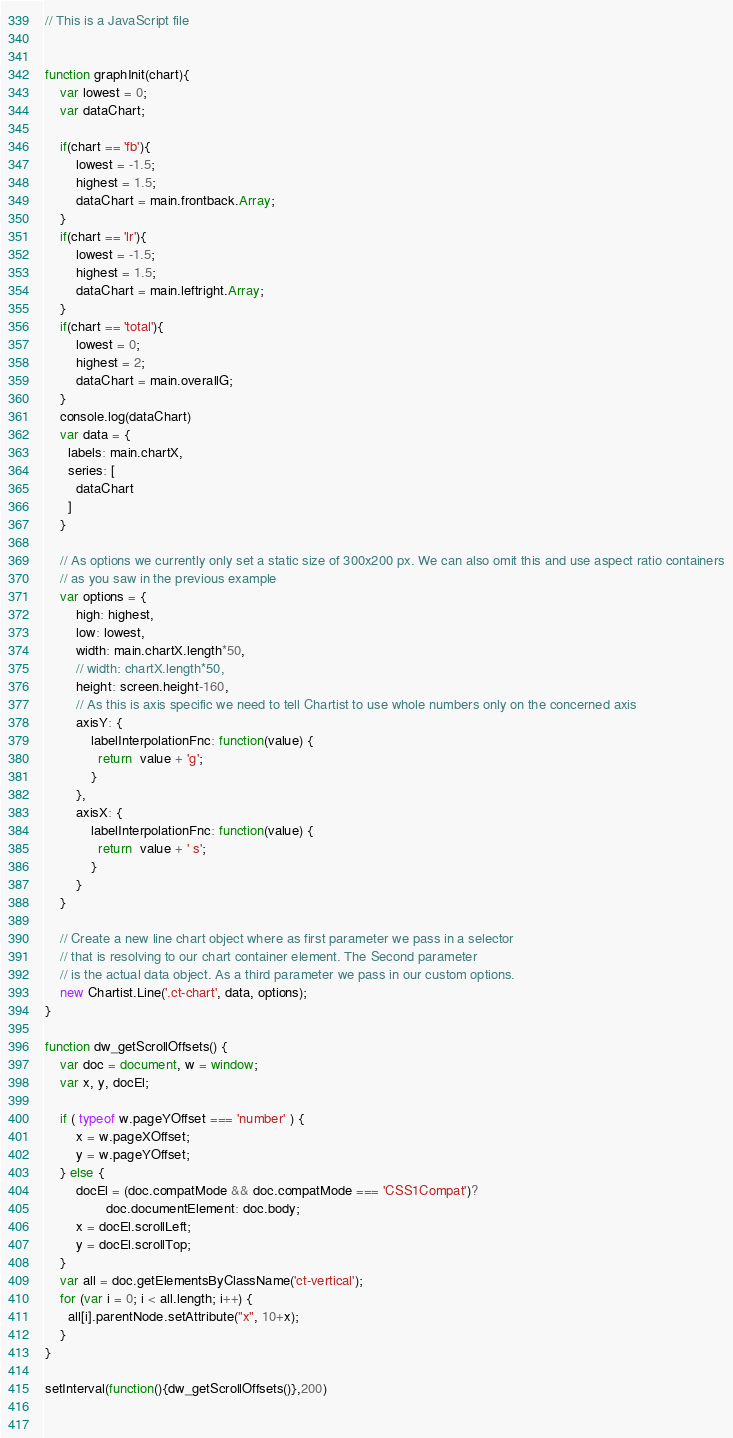Convert code to text. <code><loc_0><loc_0><loc_500><loc_500><_JavaScript_>// This is a JavaScript file


function graphInit(chart){
	var lowest = 0;
	var dataChart;

	if(chart == 'fb'){
		lowest = -1.5;
		highest = 1.5;
		dataChart = main.frontback.Array;
	}
	if(chart == 'lr'){
		lowest = -1.5;
		highest = 1.5;
		dataChart = main.leftright.Array;
	}
	if(chart == 'total'){
		lowest = 0;
		highest = 2;
		dataChart = main.overallG;
	}
	console.log(dataChart)
    var data = {
      labels: main.chartX,
      series: [
        dataChart
      ]
    }
    
    // As options we currently only set a static size of 300x200 px. We can also omit this and use aspect ratio containers
    // as you saw in the previous example
    var options = {
        high: highest,
        low: lowest,
        width: main.chartX.length*50,
        // width: chartX.length*50,
        height: screen.height-160,
        // As this is axis specific we need to tell Chartist to use whole numbers only on the concerned axis
        axisY: {
            labelInterpolationFnc: function(value) {
              return  value + 'g';
            }
        }, 
        axisX: {
            labelInterpolationFnc: function(value) {
              return  value + ' s';
            }
        }
    }
    
    // Create a new line chart object where as first parameter we pass in a selector
    // that is resolving to our chart container element. The Second parameter
    // is the actual data object. As a third parameter we pass in our custom options.
    new Chartist.Line('.ct-chart', data, options);
}
  
function dw_getScrollOffsets() {
    var doc = document, w = window;
    var x, y, docEl;
    
    if ( typeof w.pageYOffset === 'number' ) { 
        x = w.pageXOffset;
        y = w.pageYOffset;
    } else {
        docEl = (doc.compatMode && doc.compatMode === 'CSS1Compat')?
                doc.documentElement: doc.body;
        x = docEl.scrollLeft;
        y = docEl.scrollTop;
    }
    var all = doc.getElementsByClassName('ct-vertical');
    for (var i = 0; i < all.length; i++) {
	  all[i].parentNode.setAttribute("x", 10+x);
	}
}

setInterval(function(){dw_getScrollOffsets()},200)
  
  </code> 